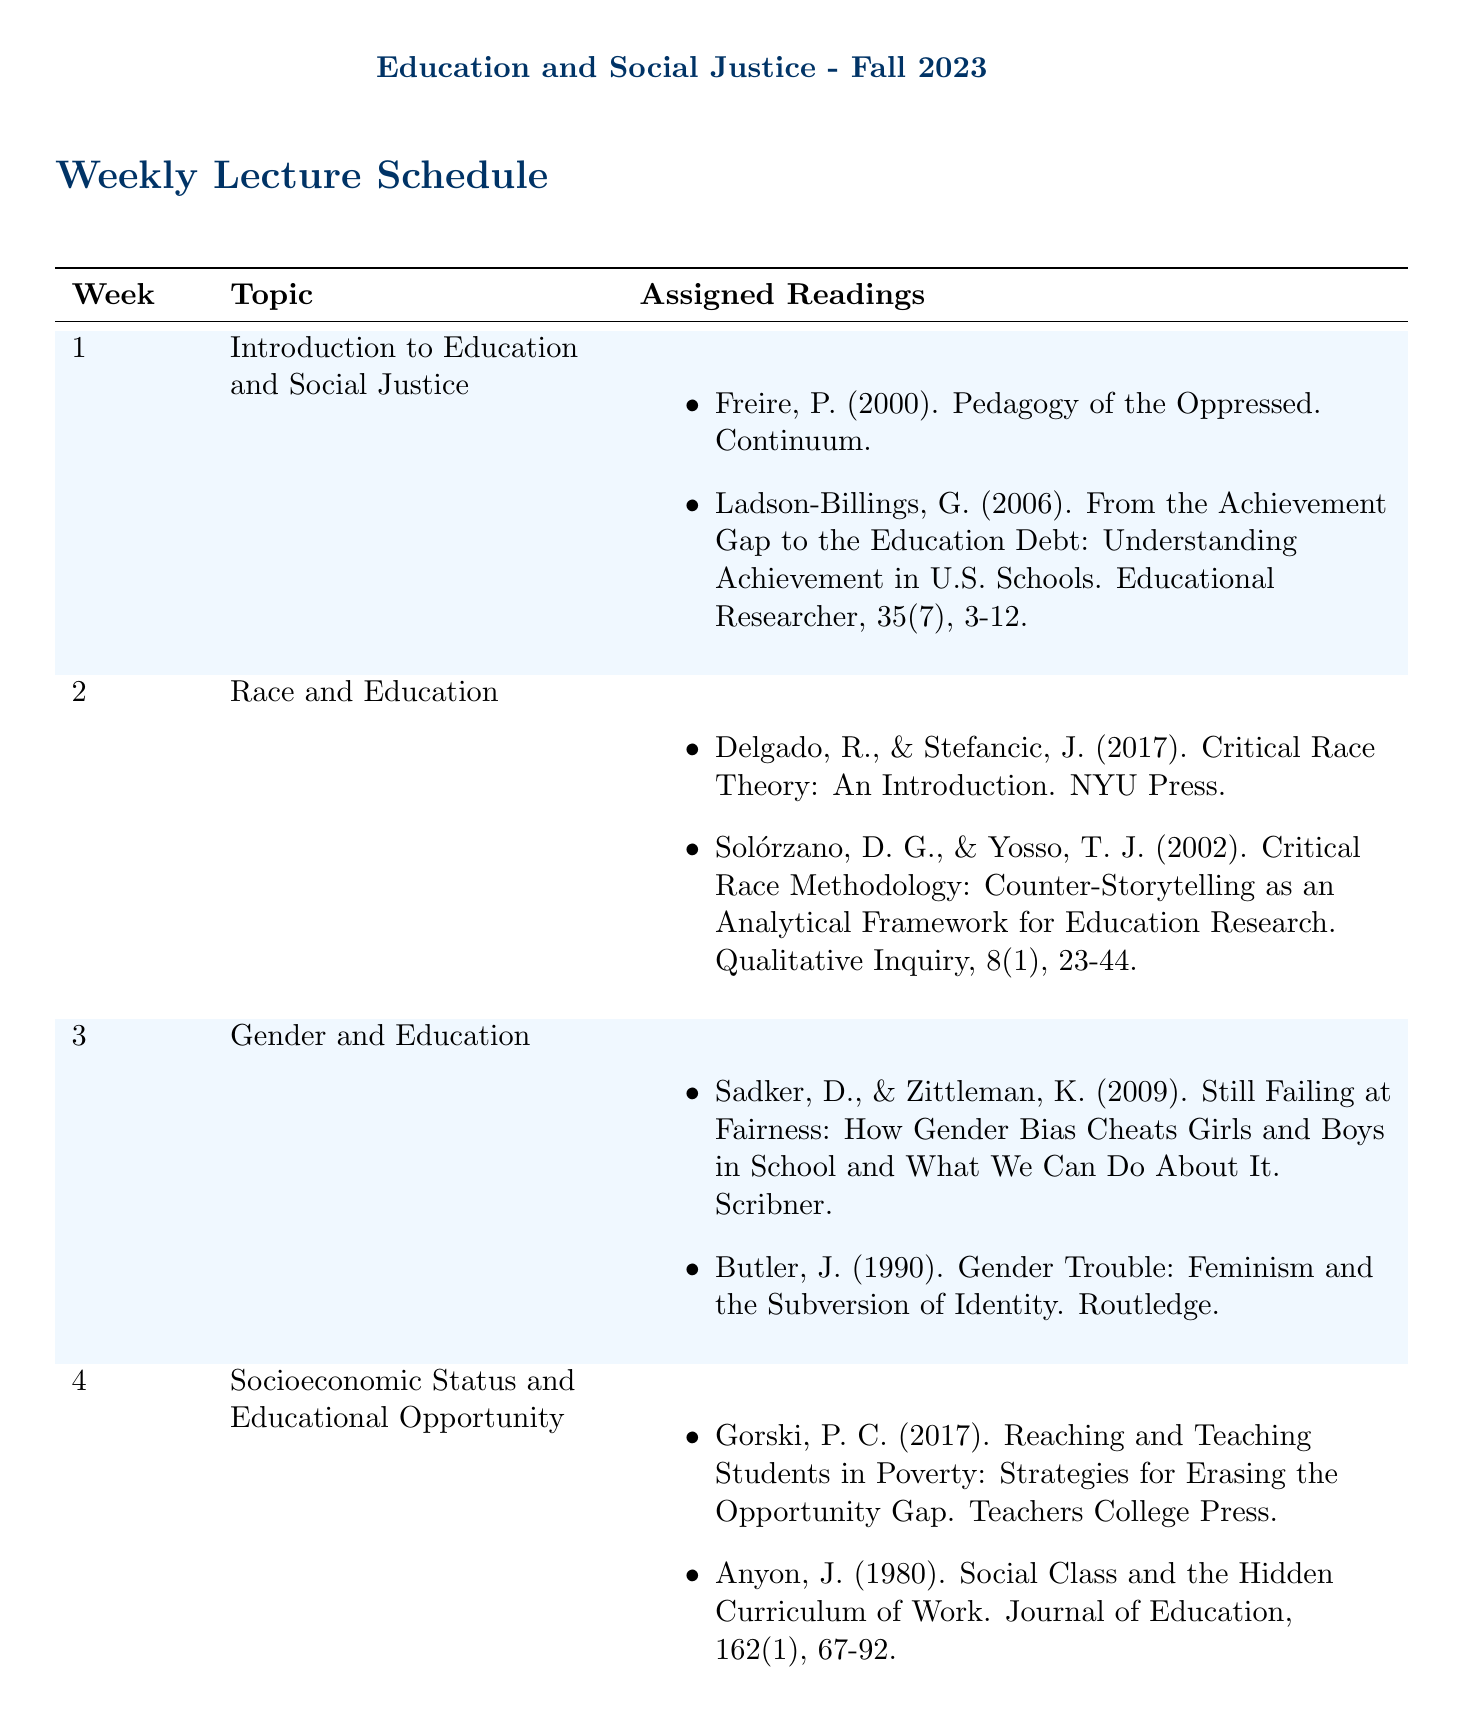What is the course title? The course title is specified at the beginning of the document under the course title section.
Answer: Education and Social Justice How many weeks are covered in the schedule? The document lists 15 weeks in the weekly schedule, indicating the total duration of the course content.
Answer: 15 What is the topic for week 4? The topic for each week is explicitly stated in the weekly schedule; for week 4, it is given directly.
Answer: Socioeconomic Status and Educational Opportunity Who are the authors of the reading assigned for week 2? The assigned readings for each week include authors' names, and for week 2, the authors can be retrieved from that week's entry.
Answer: Delgado, R., & Stefancic, J What lecture is scheduled for week 10? Each week includes a specific lecture, which is noted in the schedule under the lecture column for week 10.
Answer: Comparative Education and Social Justice Which reading is assigned for the topic of LGBTQ+ Issues in Education? The document provides assigned readings for each topic, and for the LGBTQ+ issues topic, one of the readings can be accessed easily.
Answer: LGBTQ Youth and Education: Policies and Practices What is the lecture title in week 1? The lecture title is included in the weekly schedule aligned next to the corresponding week and topic.
Answer: Foundations of Educational Equality What is the focus of week 12's assigned readings? Each week has a designated focus in terms of readings, and week 12 focuses on a specific aspect in the assigned readings.
Answer: Climate Change Education and Sustainability 